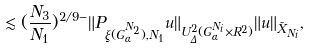<formula> <loc_0><loc_0><loc_500><loc_500>\lesssim ( \frac { N _ { 3 } } { N _ { 1 } } ) ^ { 2 / 9 - } \| P _ { \xi ( G _ { \alpha } ^ { N _ { 2 } } ) , N _ { 1 } } u \| _ { U _ { \Delta } ^ { 2 } ( G _ { \alpha } ^ { N _ { i } } \times R ^ { 2 } ) } \| u \| _ { \tilde { X } _ { N _ { i } } } ,</formula> 